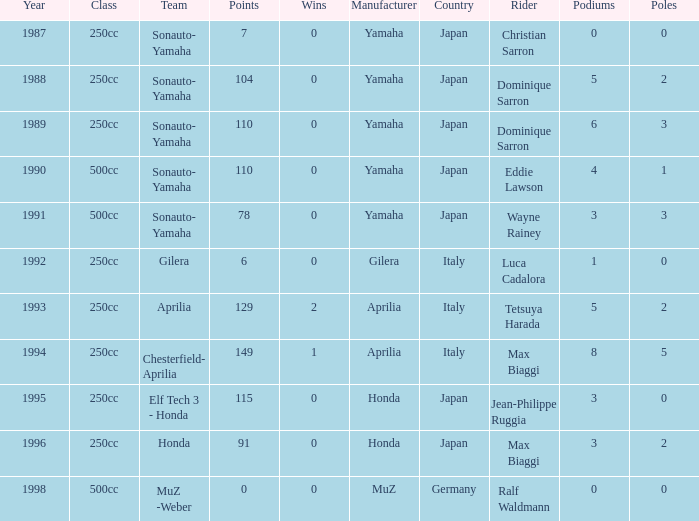What is the highest number of points the team with 0 wins had before 1992? 110.0. Could you parse the entire table? {'header': ['Year', 'Class', 'Team', 'Points', 'Wins', 'Manufacturer', 'Country', 'Rider', 'Podiums', 'Poles'], 'rows': [['1987', '250cc', 'Sonauto- Yamaha', '7', '0', 'Yamaha', 'Japan', 'Christian Sarron', '0', '0'], ['1988', '250cc', 'Sonauto- Yamaha', '104', '0', 'Yamaha', 'Japan', 'Dominique Sarron', '5', '2'], ['1989', '250cc', 'Sonauto- Yamaha', '110', '0', 'Yamaha', 'Japan', 'Dominique Sarron', '6', '3'], ['1990', '500cc', 'Sonauto- Yamaha', '110', '0', 'Yamaha', 'Japan', 'Eddie Lawson', '4', '1'], ['1991', '500cc', 'Sonauto- Yamaha', '78', '0', 'Yamaha', 'Japan', 'Wayne Rainey', '3', '3'], ['1992', '250cc', 'Gilera', '6', '0', 'Gilera', 'Italy', 'Luca Cadalora', '1', '0'], ['1993', '250cc', 'Aprilia', '129', '2', 'Aprilia', 'Italy', 'Tetsuya Harada', '5', '2'], ['1994', '250cc', 'Chesterfield- Aprilia', '149', '1', 'Aprilia', 'Italy', 'Max Biaggi', '8', '5'], ['1995', '250cc', 'Elf Tech 3 - Honda', '115', '0', 'Honda', 'Japan', 'Jean-Philippe Ruggia', '3', '0'], ['1996', '250cc', 'Honda', '91', '0', 'Honda', 'Japan', 'Max Biaggi', '3', '2'], ['1998', '500cc', 'MuZ -Weber', '0', '0', 'MuZ', 'Germany', 'Ralf Waldmann', '0', '0']]} 